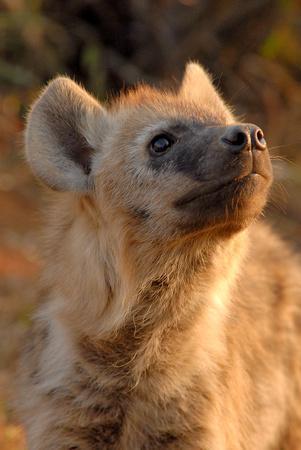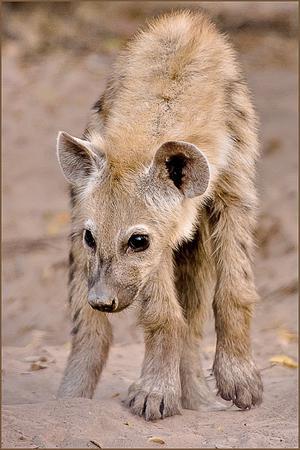The first image is the image on the left, the second image is the image on the right. Given the left and right images, does the statement "Each image contains one hyena, and the hyena on the right has its head and body turned mostly forward, with its neck not raised higher than its shoulders." hold true? Answer yes or no. Yes. The first image is the image on the left, the second image is the image on the right. Evaluate the accuracy of this statement regarding the images: "There is only one hyena that is standing in each image.". Is it true? Answer yes or no. Yes. 